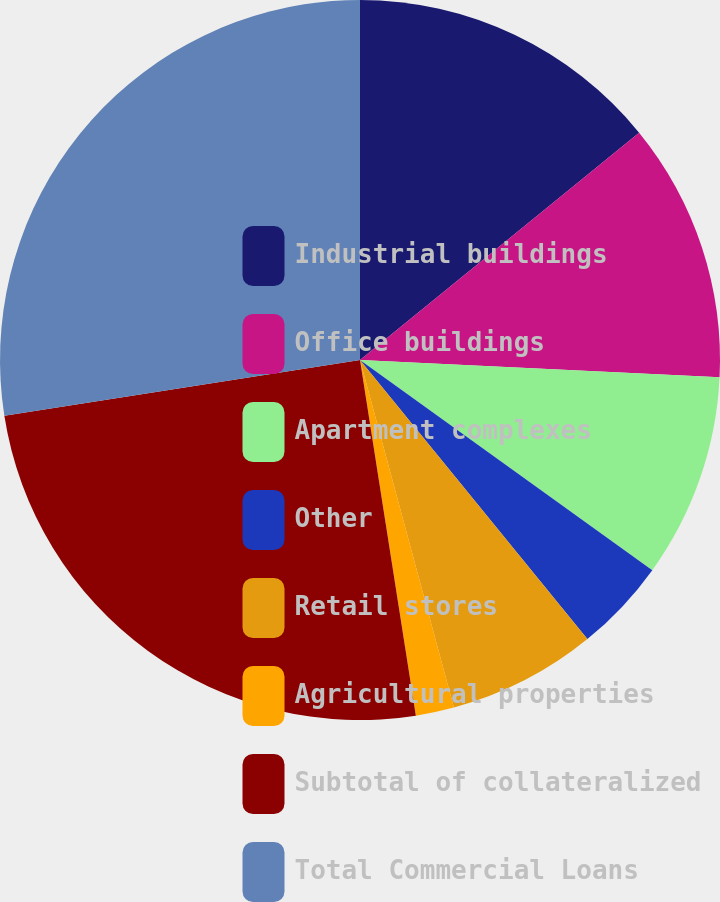Convert chart to OTSL. <chart><loc_0><loc_0><loc_500><loc_500><pie_chart><fcel>Industrial buildings<fcel>Office buildings<fcel>Apartment complexes<fcel>Other<fcel>Retail stores<fcel>Agricultural properties<fcel>Subtotal of collateralized<fcel>Total Commercial Loans<nl><fcel>14.12%<fcel>11.64%<fcel>9.16%<fcel>4.2%<fcel>6.68%<fcel>1.72%<fcel>25.0%<fcel>27.48%<nl></chart> 